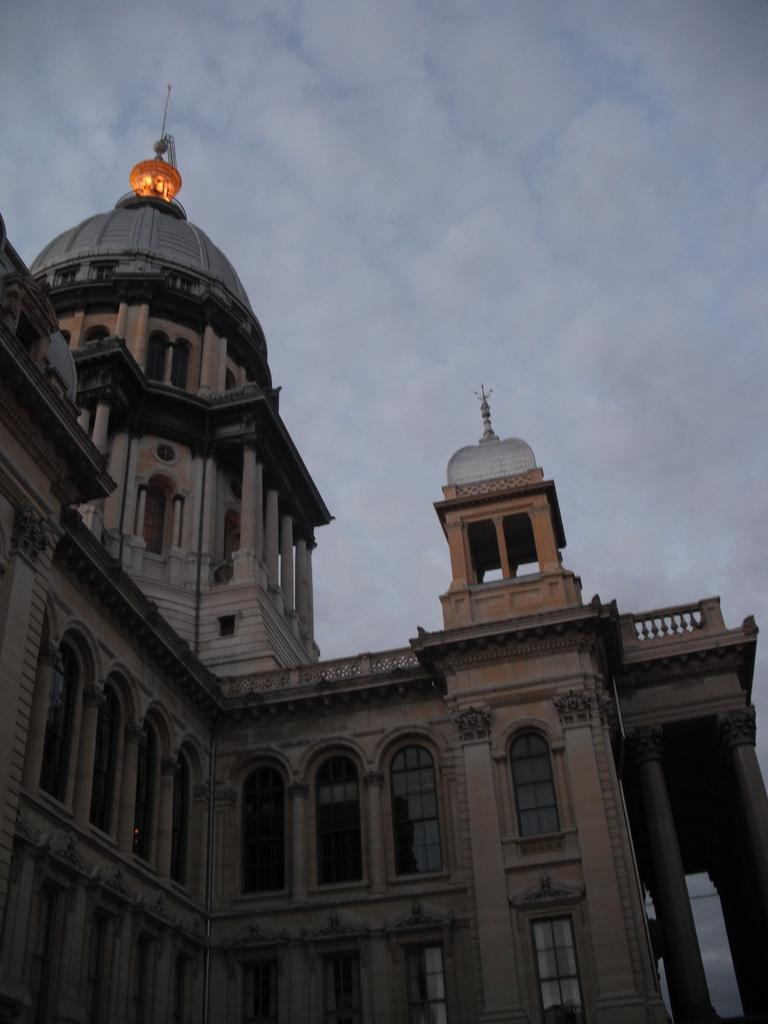What type of structure is present in the image? There is a building in the image. What architectural features can be seen on the building? The building has windows, pillars, and arches. What is on top of the building? There is light on top of the building. What can be seen in the background of the image? There is sky visible in the background of the image, and there are clouds in the sky. What type of mint is growing on the building in the image? There is no mint growing on the building in the image. How many times do the people in the image kiss each other? There are no people visible in the image, so it is impossible to determine if they are kissing or how many times. 